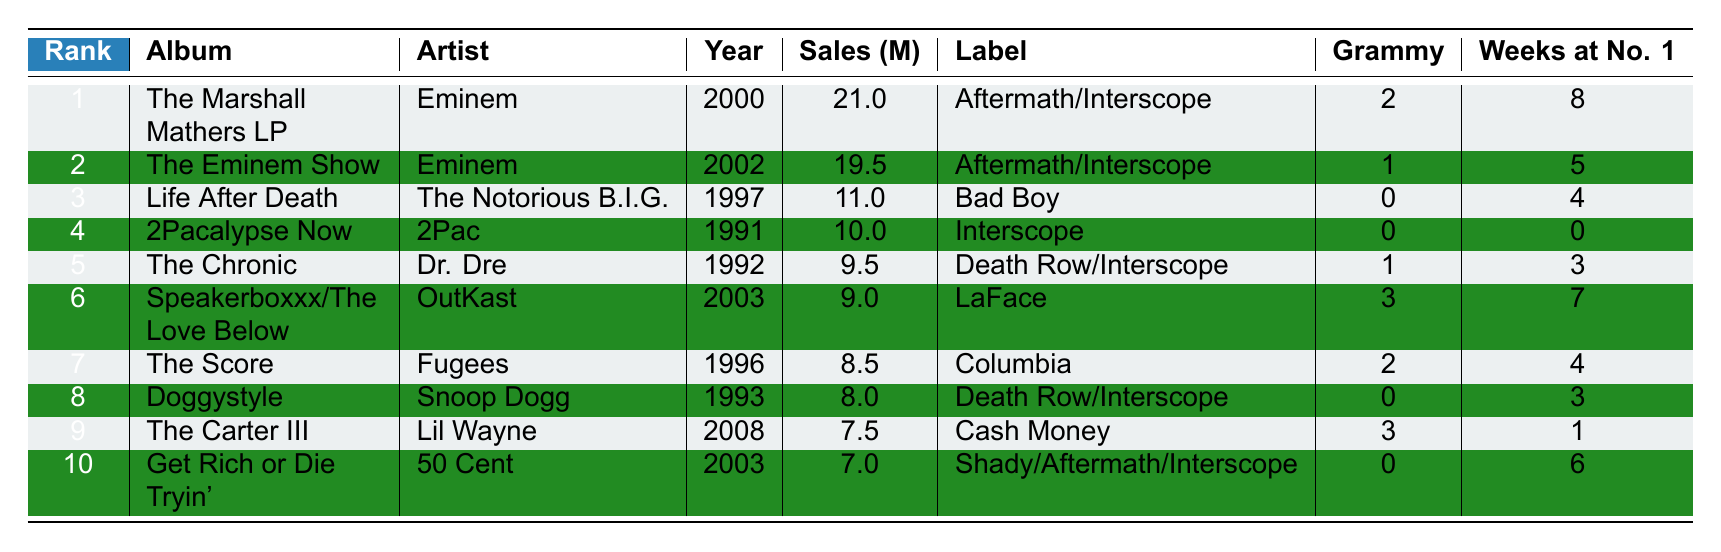What is the best-selling hip-hop album of all time? The table shows that "The Marshall Mathers LP" by Eminem is ranked first with 21 million sales.
Answer: The Marshall Mathers LP Which artist has the most albums in the top 10? By examining the table, Eminem appears twice with "The Marshall Mathers LP" and "The Eminem Show." No other artist appears more than once.
Answer: Eminem How many albums sold over 10 million copies? Looking at the sales figures, there are three albums that sold over 10 million copies: "The Marshall Mathers LP," "The Eminem Show," and "Life After Death."
Answer: Three Which album by 2Pac is listed in the top 10? The table lists "2Pacalypse Now" by 2Pac as ranked 4th.
Answer: 2Pacalypse Now What is the total sales of the top 10 albums? Adding the sales of the albums gives: 21 + 19.5 + 11 + 10 + 9.5 + 9 + 8.5 + 8 + 7.5 + 7 = 93 million.
Answer: 93 million Which album had the most Grammy Awards? "Speakerboxxx/The Love Below" by OutKast received the most Grammy Awards with a total of 3.
Answer: Speakerboxxx/The Love Below Is "Get Rich or Die Tryin'" the only album by 50 Cent in the top 10? The table shows that "Get Rich or Die Tryin'" is the only album listed for 50 Cent.
Answer: Yes What was the average number of weeks at No. 1 for the top 10 albums? Calculating the total weeks at No. 1: 8 + 5 + 4 + 0 + 3 + 7 + 4 + 3 + 1 + 6 = 41 weeks. There are 10 albums, so the average is 41 / 10 = 4.1 weeks.
Answer: 4.1 weeks Which album had the lowest sales and how many copies did it sell? "Get Rich or Die Tryin'" by 50 Cent sold the lowest at 7 million copies.
Answer: 7 million Was there any album that has zero Grammy Awards? According to the table, both "Life After Death" and "2Pacalypse Now" received zero Grammy Awards, so the answer is yes.
Answer: Yes 